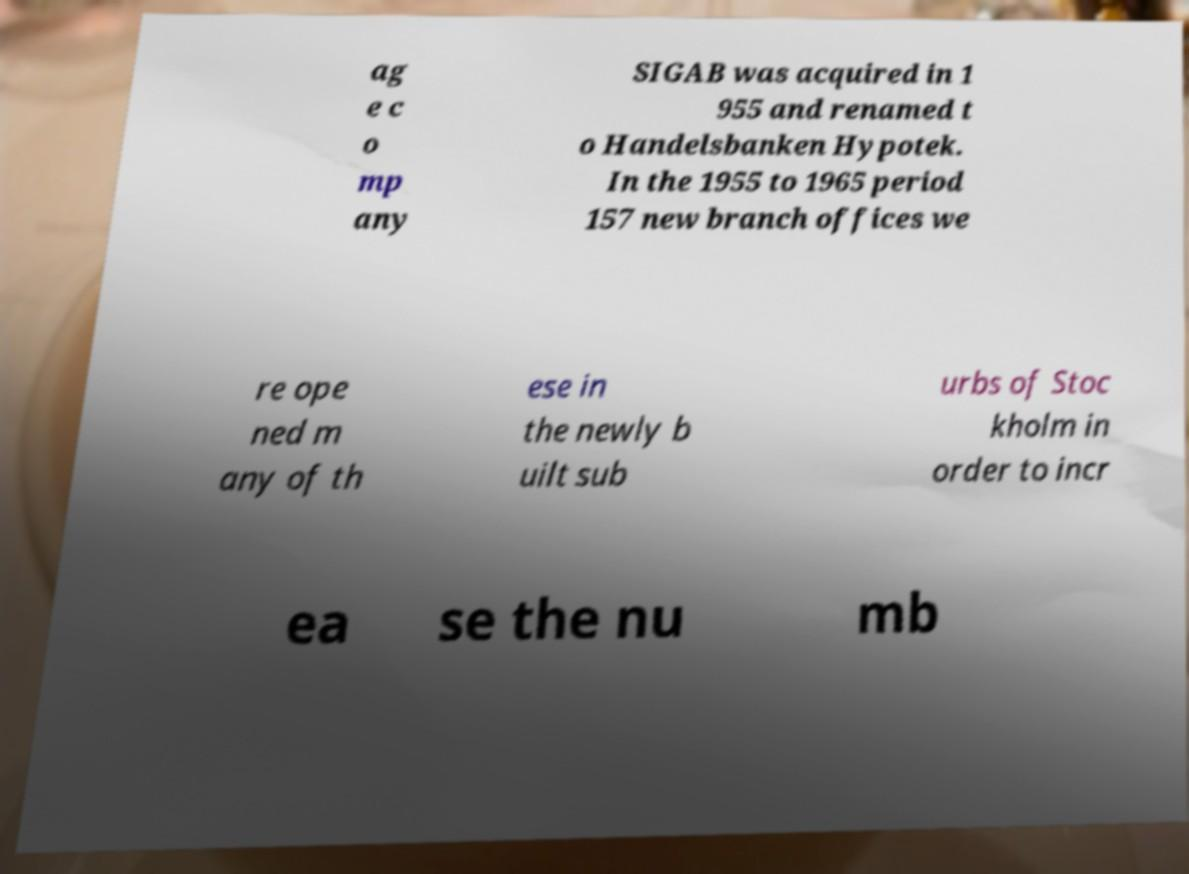Can you accurately transcribe the text from the provided image for me? ag e c o mp any SIGAB was acquired in 1 955 and renamed t o Handelsbanken Hypotek. In the 1955 to 1965 period 157 new branch offices we re ope ned m any of th ese in the newly b uilt sub urbs of Stoc kholm in order to incr ea se the nu mb 